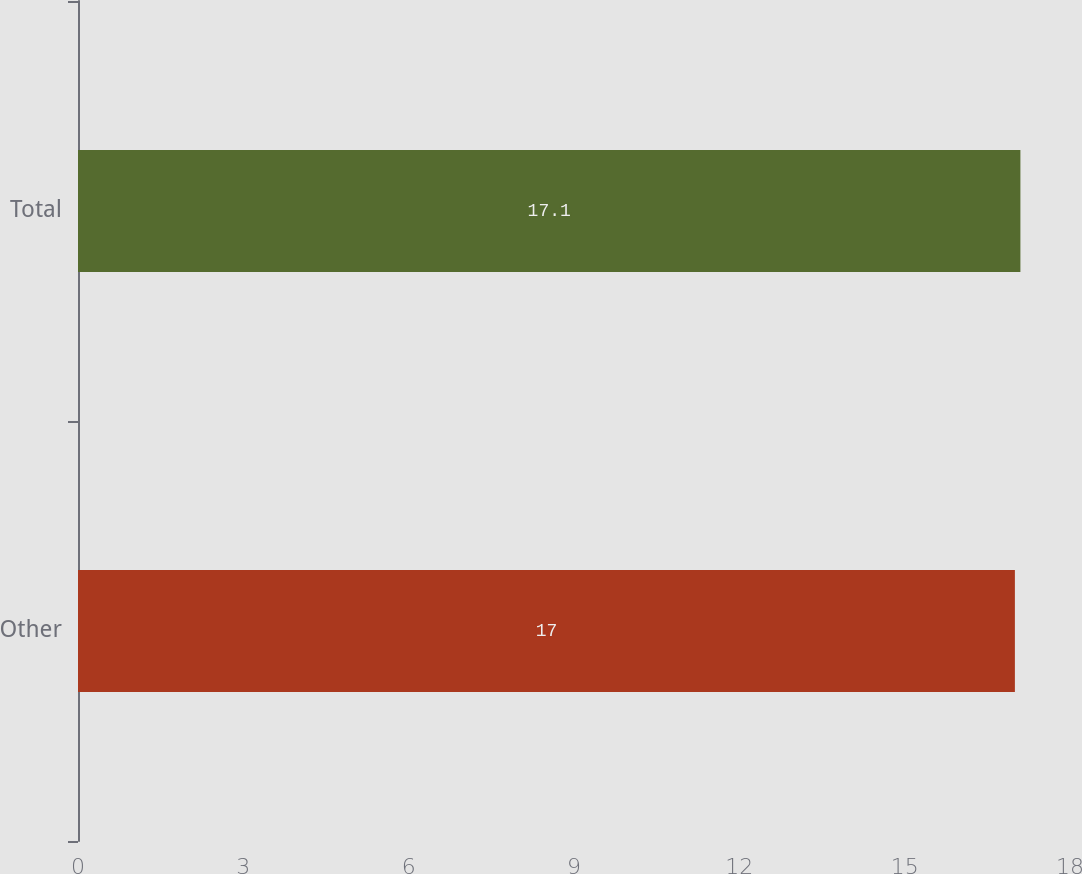Convert chart to OTSL. <chart><loc_0><loc_0><loc_500><loc_500><bar_chart><fcel>Other<fcel>Total<nl><fcel>17<fcel>17.1<nl></chart> 